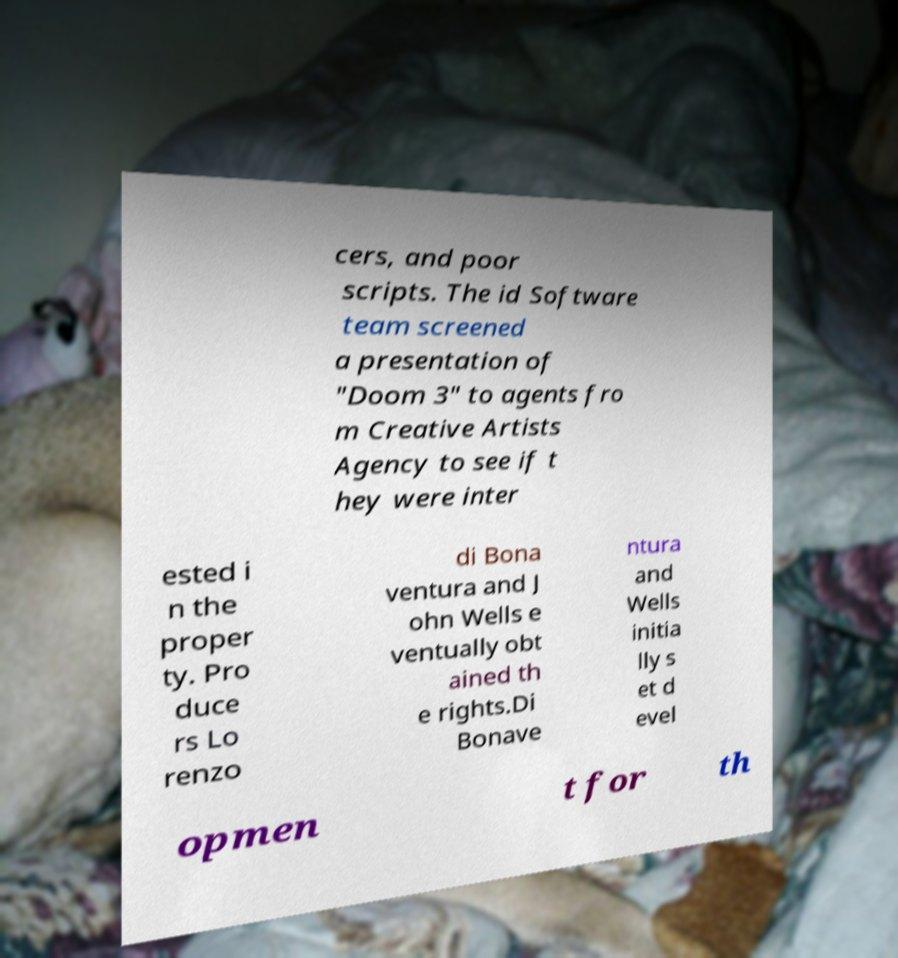For documentation purposes, I need the text within this image transcribed. Could you provide that? cers, and poor scripts. The id Software team screened a presentation of "Doom 3" to agents fro m Creative Artists Agency to see if t hey were inter ested i n the proper ty. Pro duce rs Lo renzo di Bona ventura and J ohn Wells e ventually obt ained th e rights.Di Bonave ntura and Wells initia lly s et d evel opmen t for th 